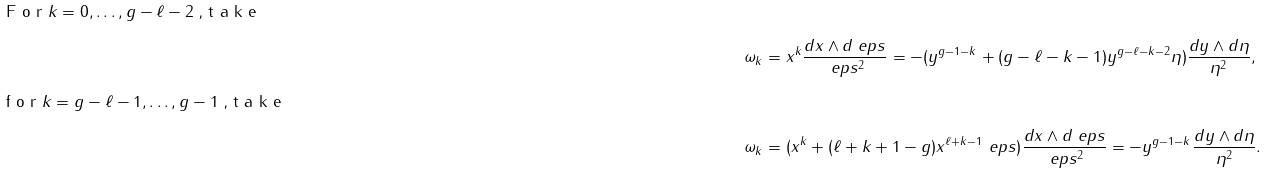Convert formula to latex. <formula><loc_0><loc_0><loc_500><loc_500>\intertext { F o r $ k = 0 , \dots , g - \ell - 2 $ , t a k e } \omega _ { k } & = x ^ { k } \frac { d x \wedge d \ e p s } { \ e p s ^ { 2 } } = - ( y ^ { g - 1 - k } + ( g - \ell - k - 1 ) y ^ { g - \ell - k - 2 } \eta ) \frac { d y \wedge d \eta } { \eta ^ { 2 } } , \\ \intertext { f o r $ k = g - \ell - 1 , \dots , g - 1 $ , t a k e } \omega _ { k } & = ( x ^ { k } + ( \ell + k + 1 - g ) x ^ { \ell + k - 1 } \ e p s ) \frac { d x \wedge d \ e p s } { \ e p s ^ { 2 } } = - y ^ { g - 1 - k } \frac { d y \wedge d \eta } { \eta ^ { 2 } } .</formula> 